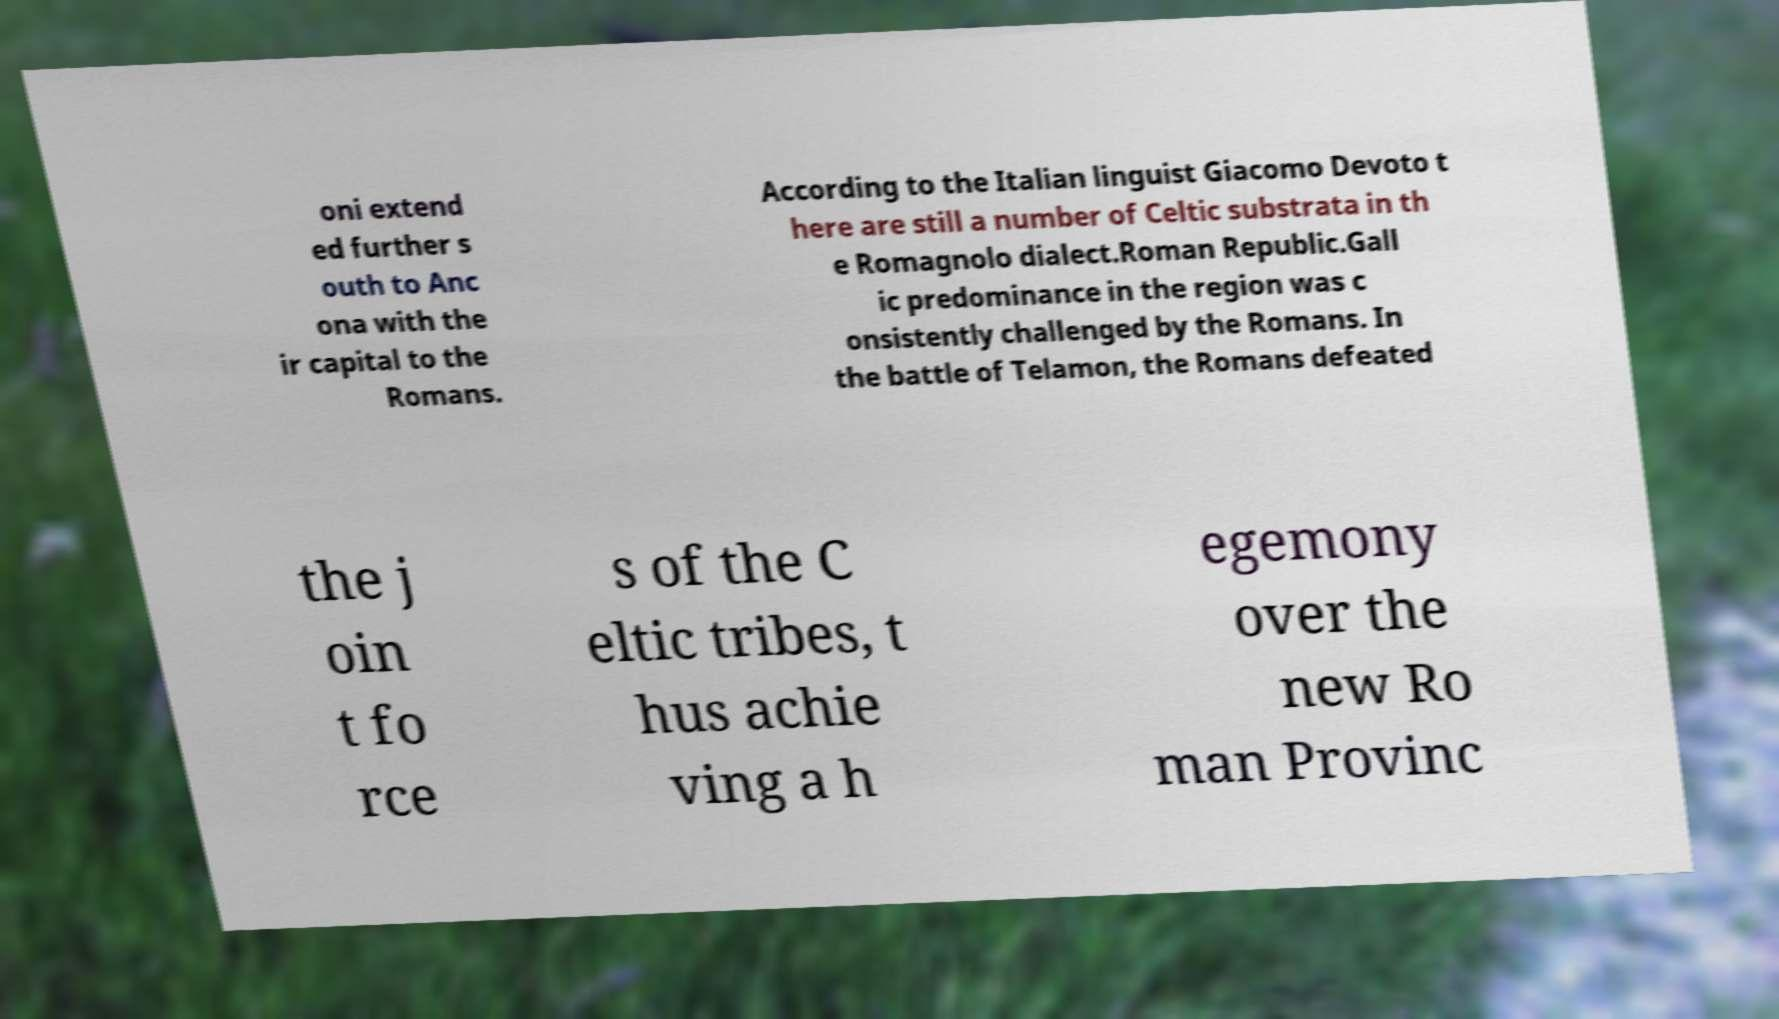There's text embedded in this image that I need extracted. Can you transcribe it verbatim? oni extend ed further s outh to Anc ona with the ir capital to the Romans. According to the Italian linguist Giacomo Devoto t here are still a number of Celtic substrata in th e Romagnolo dialect.Roman Republic.Gall ic predominance in the region was c onsistently challenged by the Romans. In the battle of Telamon, the Romans defeated the j oin t fo rce s of the C eltic tribes, t hus achie ving a h egemony over the new Ro man Provinc 